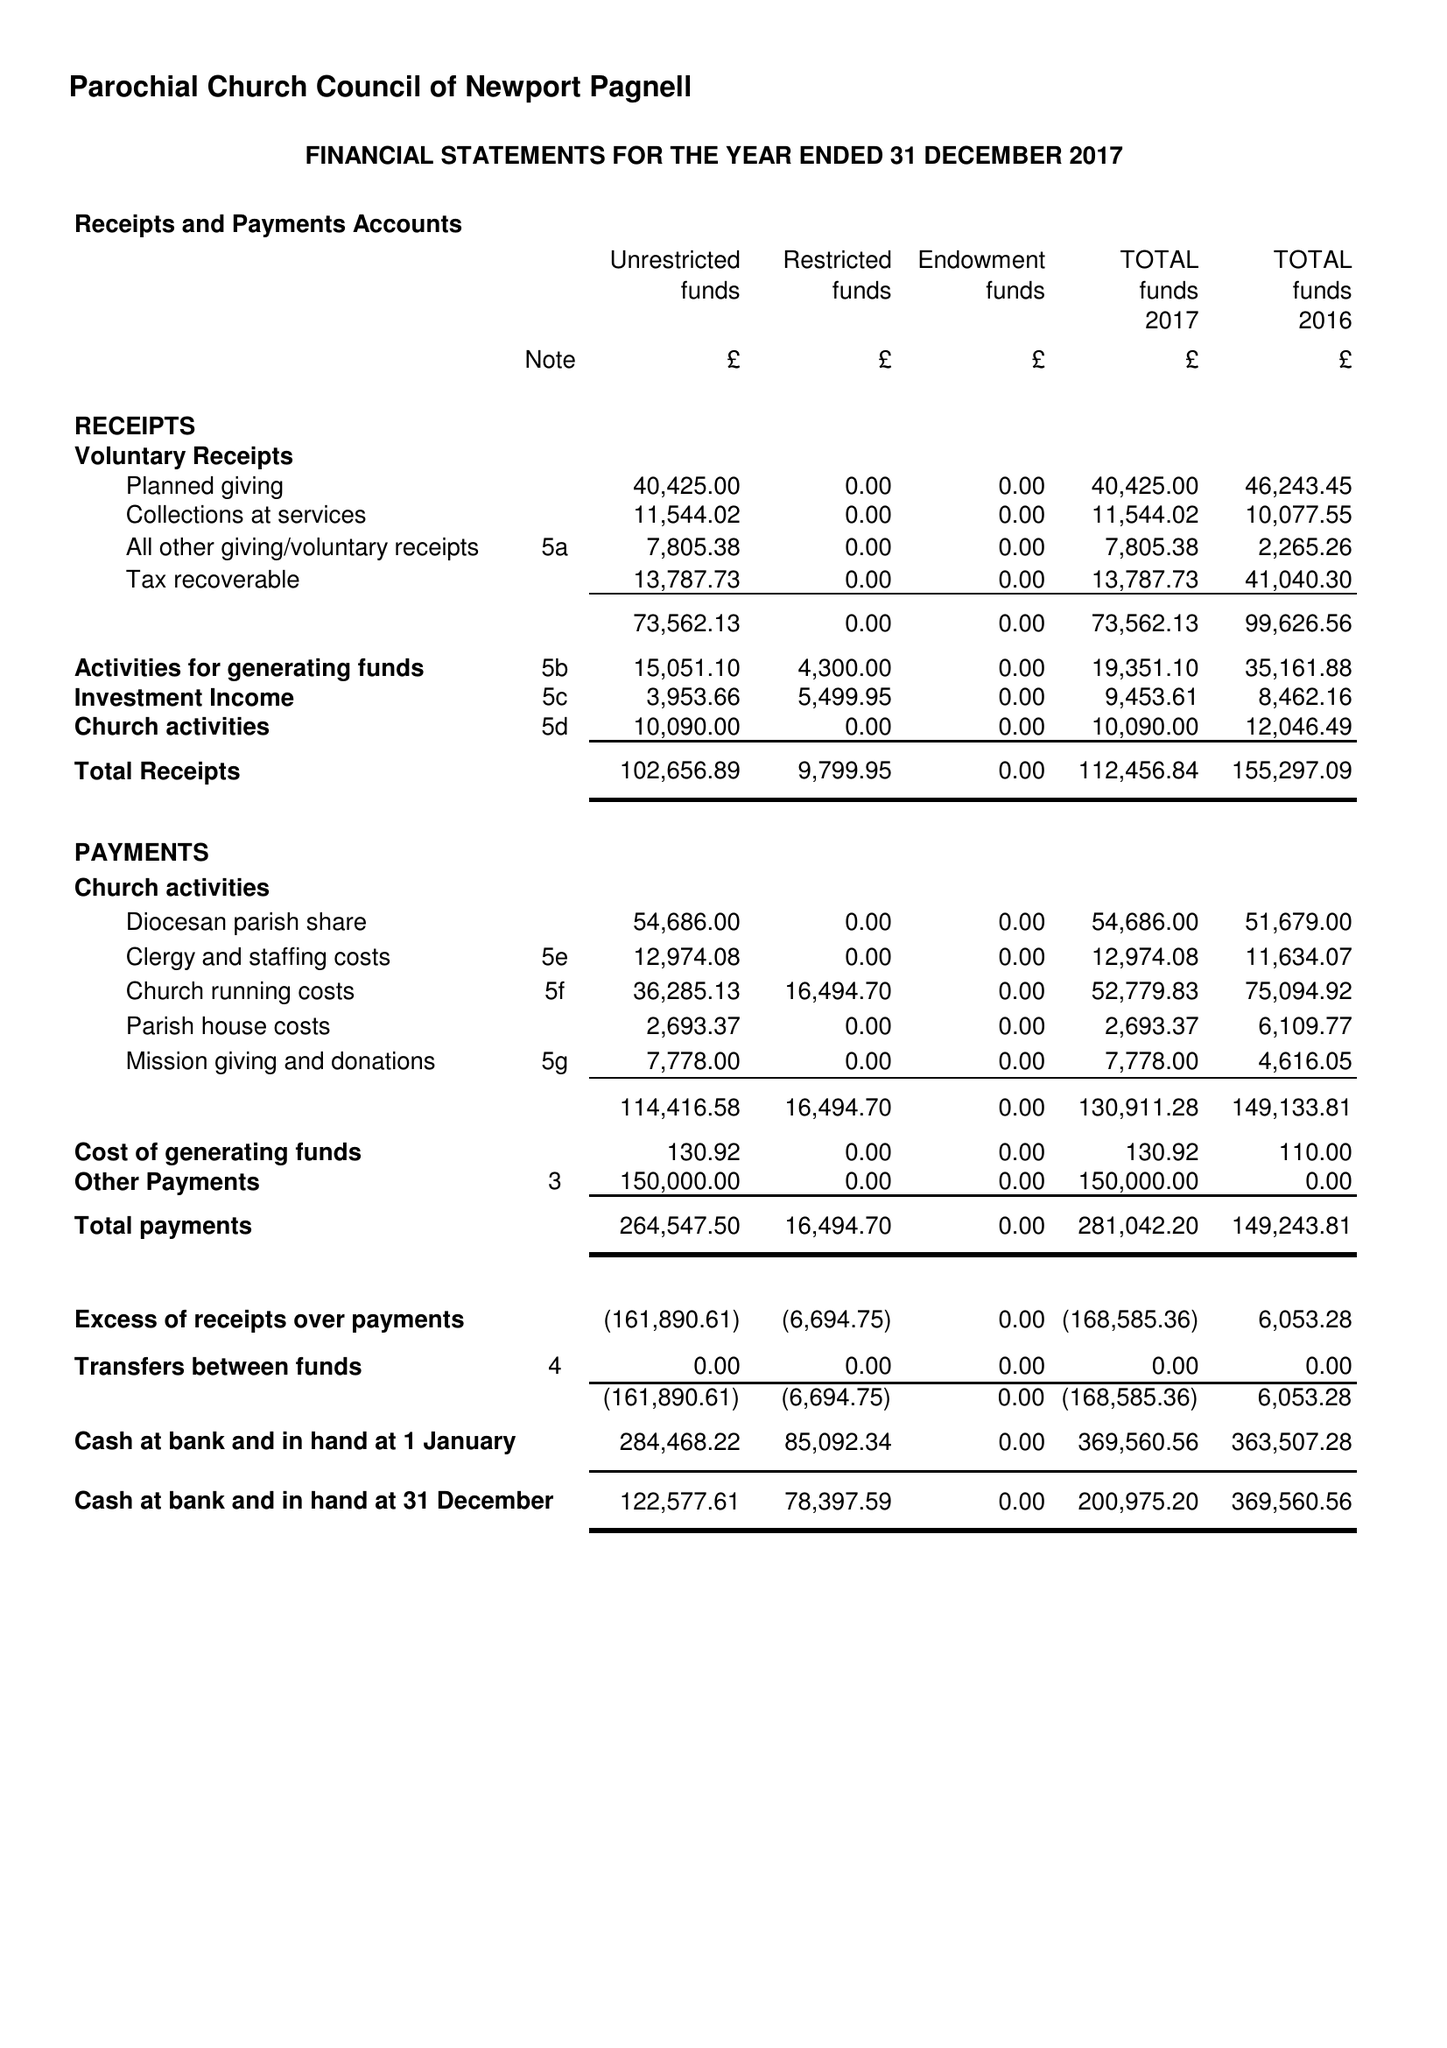What is the value for the address__street_line?
Answer the question using a single word or phrase. HIGH STREET 